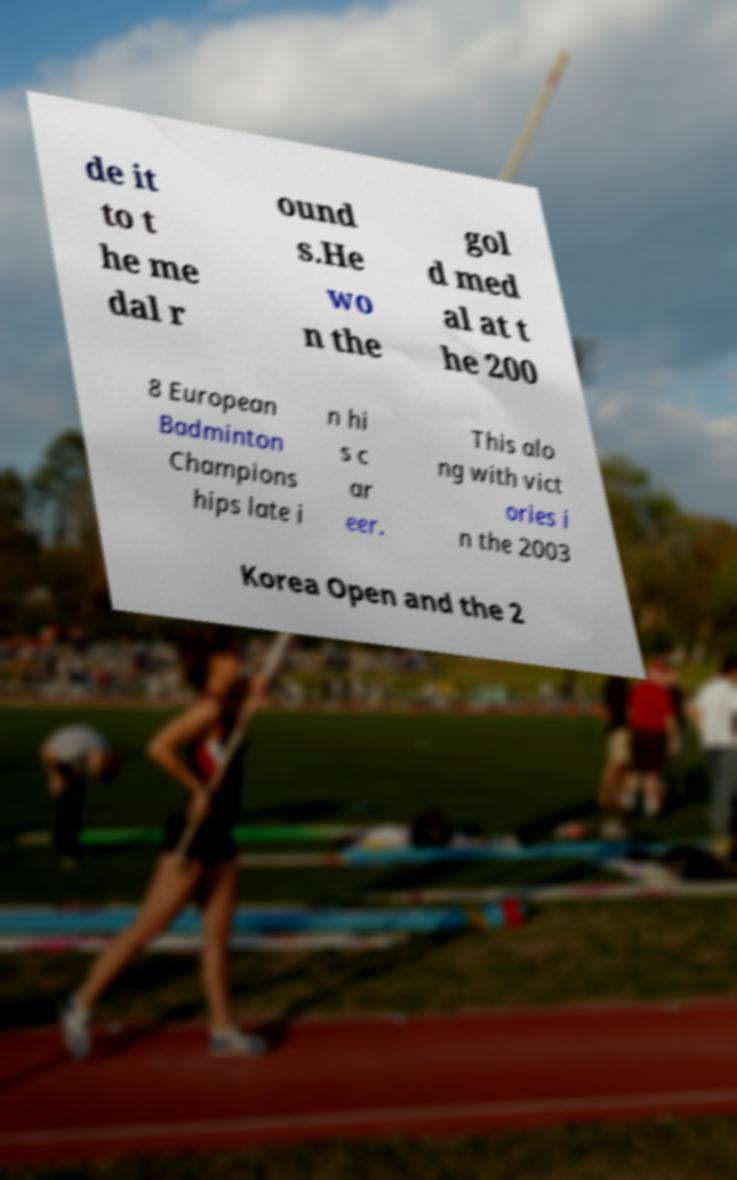There's text embedded in this image that I need extracted. Can you transcribe it verbatim? de it to t he me dal r ound s.He wo n the gol d med al at t he 200 8 European Badminton Champions hips late i n hi s c ar eer. This alo ng with vict ories i n the 2003 Korea Open and the 2 